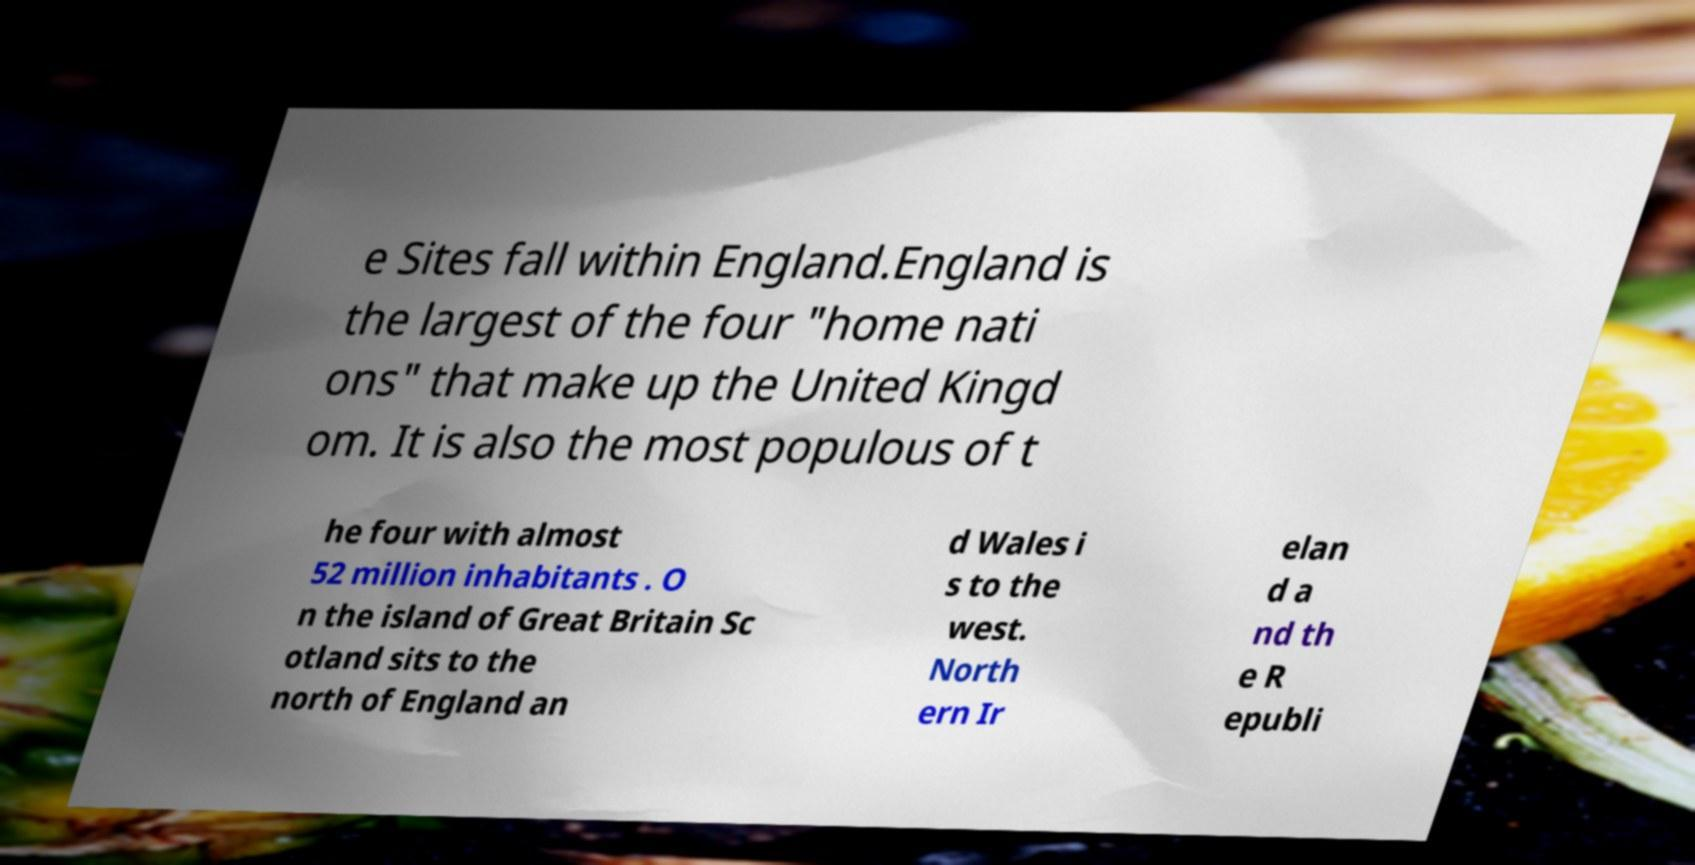For documentation purposes, I need the text within this image transcribed. Could you provide that? e Sites fall within England.England is the largest of the four "home nati ons" that make up the United Kingd om. It is also the most populous of t he four with almost 52 million inhabitants . O n the island of Great Britain Sc otland sits to the north of England an d Wales i s to the west. North ern Ir elan d a nd th e R epubli 